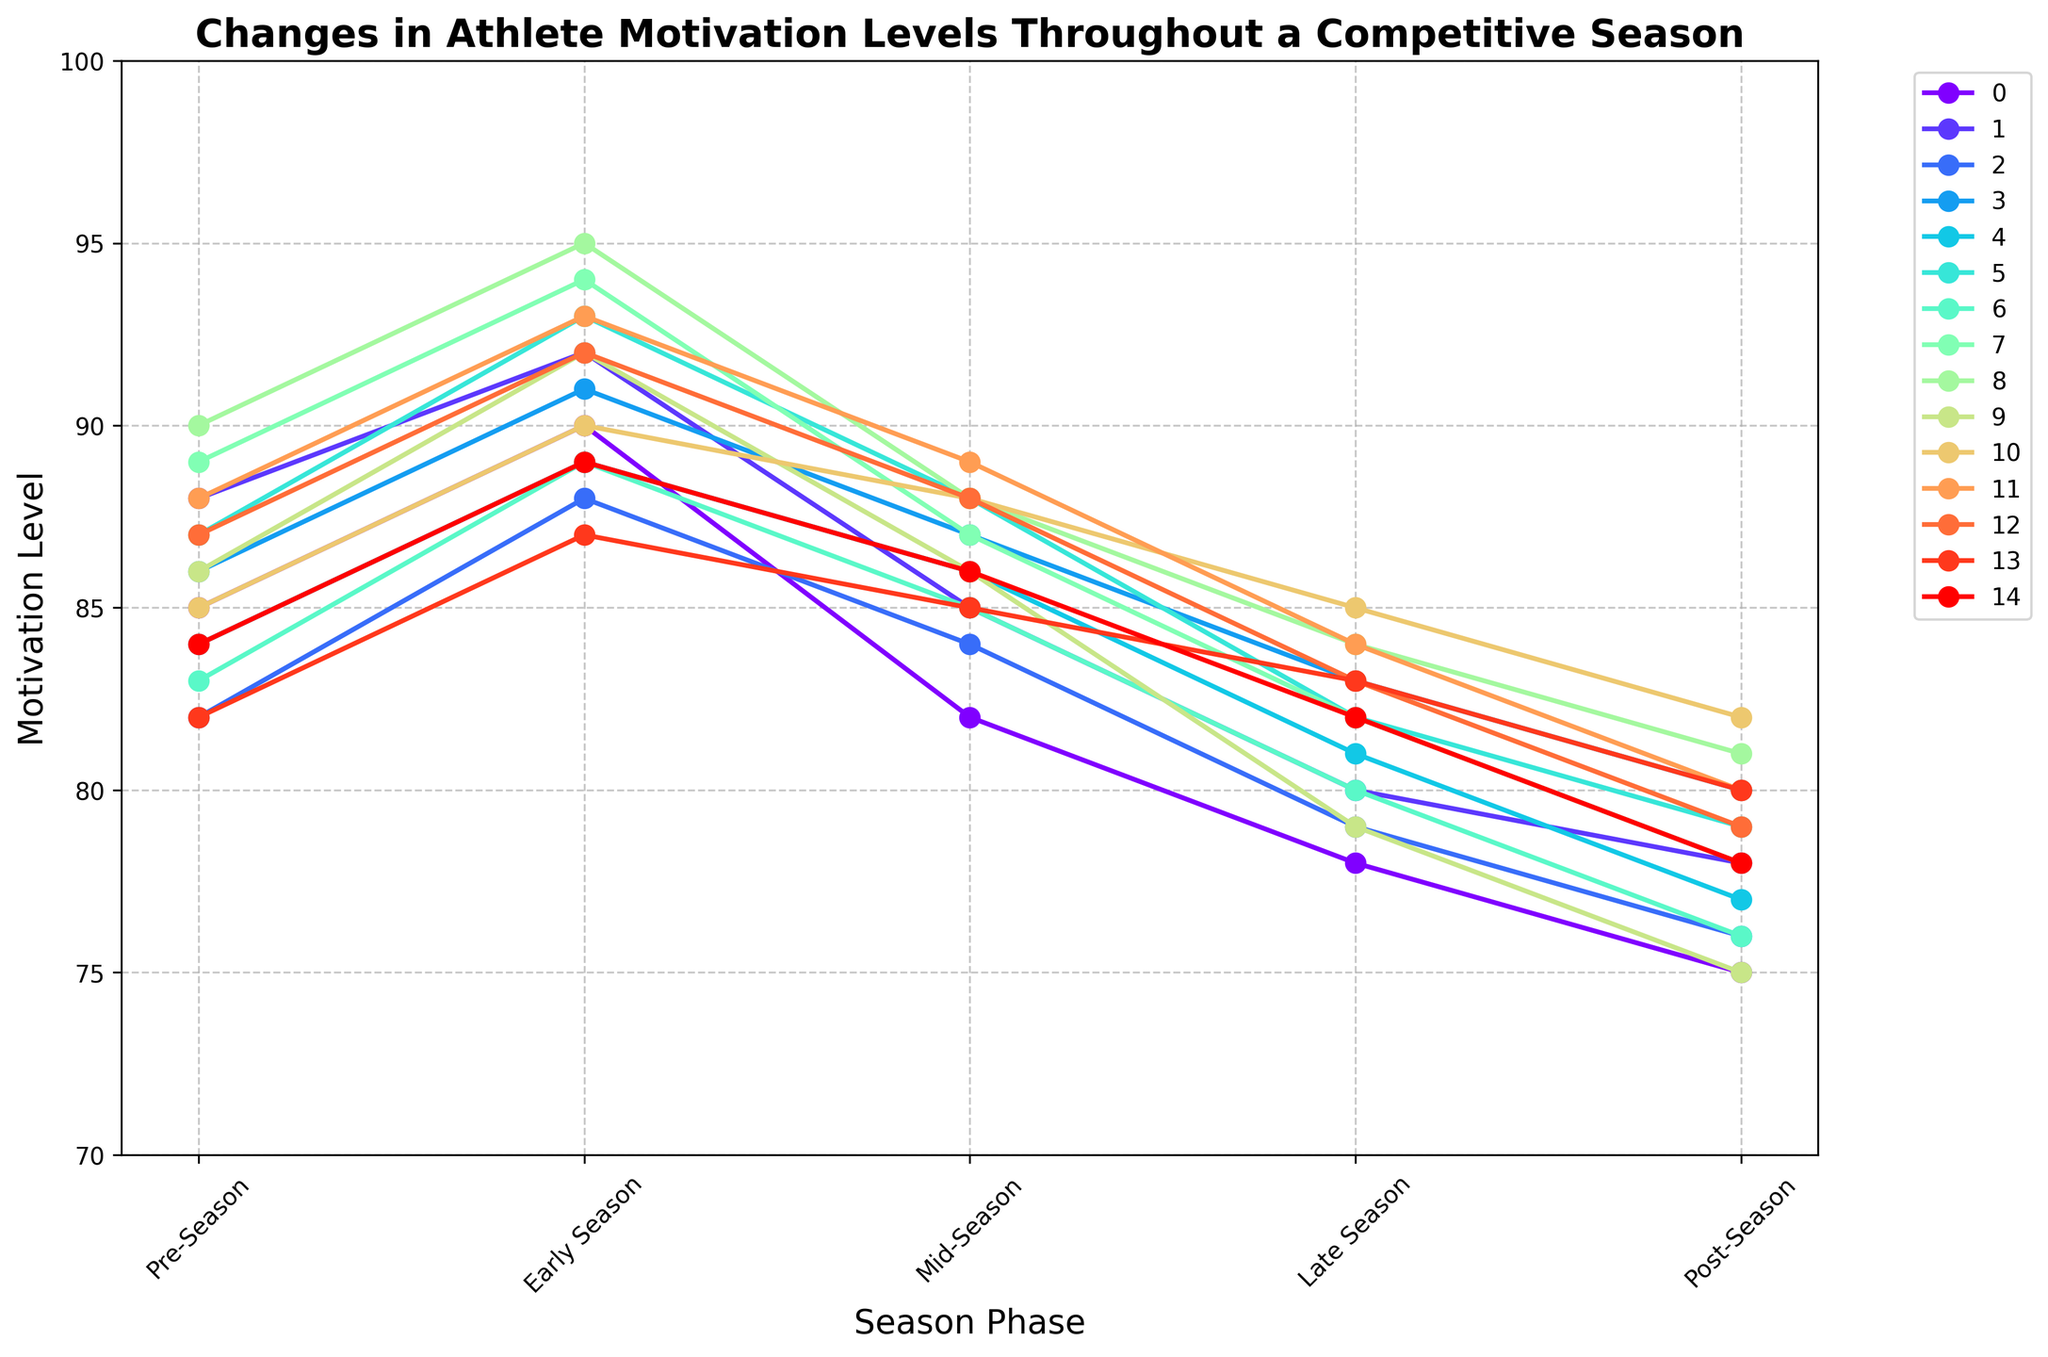What's the trend in motivation for Soccer from Pre-Season to Post-Season? The data shows Soccer motivation levels at 85 in Pre-Season, increasing to 90 in Early Season, decreasing to 82 in Mid-Season, further decreasing to 78 in Late Season, and finally decreasing to 75 in Post-Season. The trend is an initial increase during Early Season, followed by a decreasing trend towards the end of the season.
Answer: Initial increase, then decrease Which sport shows the highest motivation in the Early Season? By looking at the Early Season data points, Gymnastics shows the highest motivation level at 95.
Answer: Gymnastics Compare the Post-Season motivation levels between Swimming and Cycling. Which one is higher? The Post-Season motivation level for Swimming is 80, while for Cycling, it is 82. Comparing these two, Cycling has a higher Post-Season motivation level.
Answer: Cycling What are the average motivation levels in the Mid-Season for all sports? Sum the Mid-Season values for all sports: (82+85+84+87+86+88+85+87+88+86+88+89+88+85+86) = 1298. There are 15 sports, so the average motivation level for Mid-Season is 1298/15 ≈ 86.53
Answer: 86.53 Which sport has the most significant drop in motivation from Early Season to Post-Season? Calculate the difference for each sport and find the highest: Soccer (90-75=15), Basketball (92-78=14), Tennis (88-76=12), Swimming (91-80=11), Track and Field (89-77=12), Volleyball (93-79=14), Baseball (89-76=13), Hockey (94-78=16), Gymnastics (95-81=14), Rugby (92-75=17), Cycling (90-82=8), Wrestling (93-80=13), Figure Skating (92-79=13), Golf (87-80=7), Rowing (89-78=11). Rugby has the most significant drop of 17 points.
Answer: Rugby What's the median motivation level in Late Season across all sports? Arrange Late Season values: (78,79,79,80,81,82,82,82,83,84,84,85,86,86,87). The median value is the 8th number in the sorted list (middle value), which is 82.
Answer: 82 How do motivation levels in Gymnastics change from Pre-Season to Post-Season? Gymnastics shows the following motivation levels: Pre-Season (90), Early Season (95), Mid-Season (88), Late Season (84), Post-Season (81). The motivation increases from Pre-Season to Early Season, then decreases steadily towards the Post-Season.
Answer: Increases then decreases What is the average increase in motivation from Pre-Season to Early Season for all sports? Calculate the increase for each sport and then the average increase: Soccer (90-85=5), Basketball (92-88=4), Tennis (88-82=6), Swimming (91-86=5), Track and Field (89-84=5), Volleyball (93-87=6), Baseball (89-83=6), Hockey (94-89=5), Gymnastics (95-90=5), Rugby (92-86=6), Cycling (90-85=5), Wrestling (93-88=5), Figure Skating (92-87=5), Golf (87-82=5), Rowing (89-84=5). Sum these increments (5+4+6+5+5+6+6+5+5+6+5+5+5+5+5) = 78. The average increase is 78/15 = 5.2
Answer: 5.2 Which sport shows the least variation in motivation levels throughout the season? Calculate the range (max-min) for each sport and find the smallest one: Soccer (90-75=15), Basketball (92-78=14), Tennis (88-76=12), Swimming (91-80=11), Track and Field (89-77=12), Volleyball (93-79=14), Baseball (89-76=13), Hockey (94-78=16), Gymnastics (95-81=14), Rugby (92-75=17), Cycling (90-82=8), Wrestling (93-80=13), Figure Skating (92-79=13), Golf (87-80=7), Rowing (89-78=11). Golf shows the least variation with a range of 7 points.
Answer: Golf 